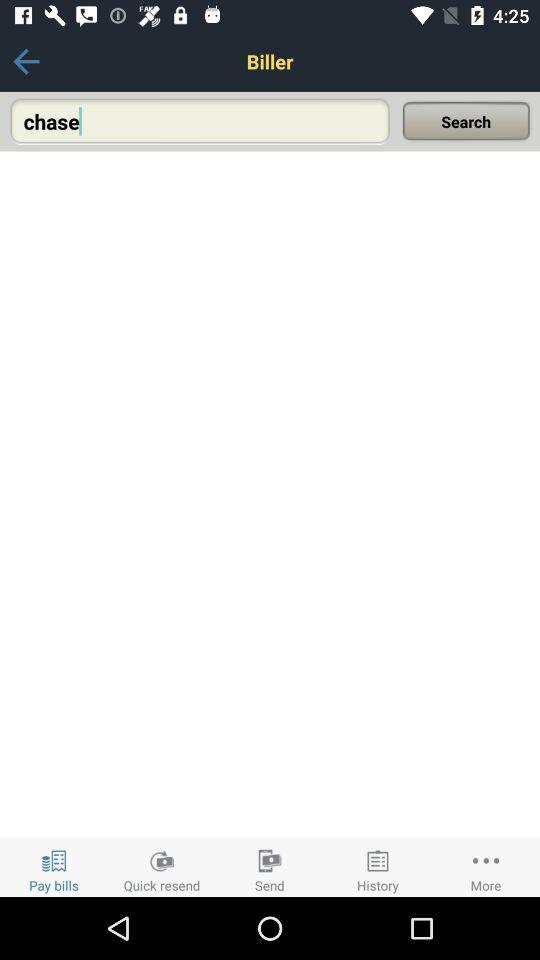Which tab is selected? The selected tab is "Pay bills". 